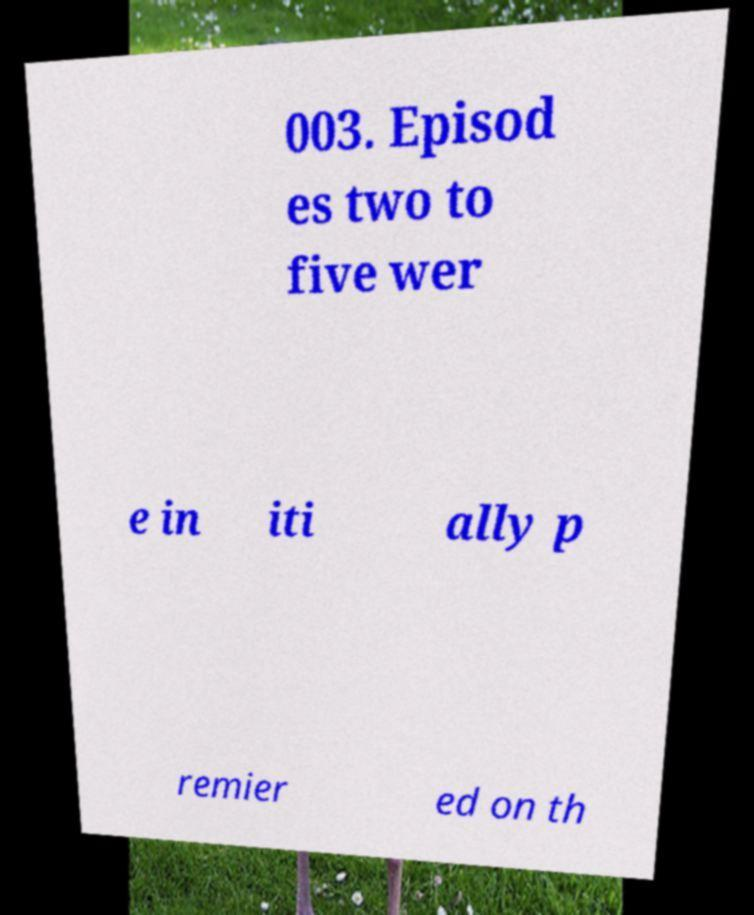For documentation purposes, I need the text within this image transcribed. Could you provide that? 003. Episod es two to five wer e in iti ally p remier ed on th 